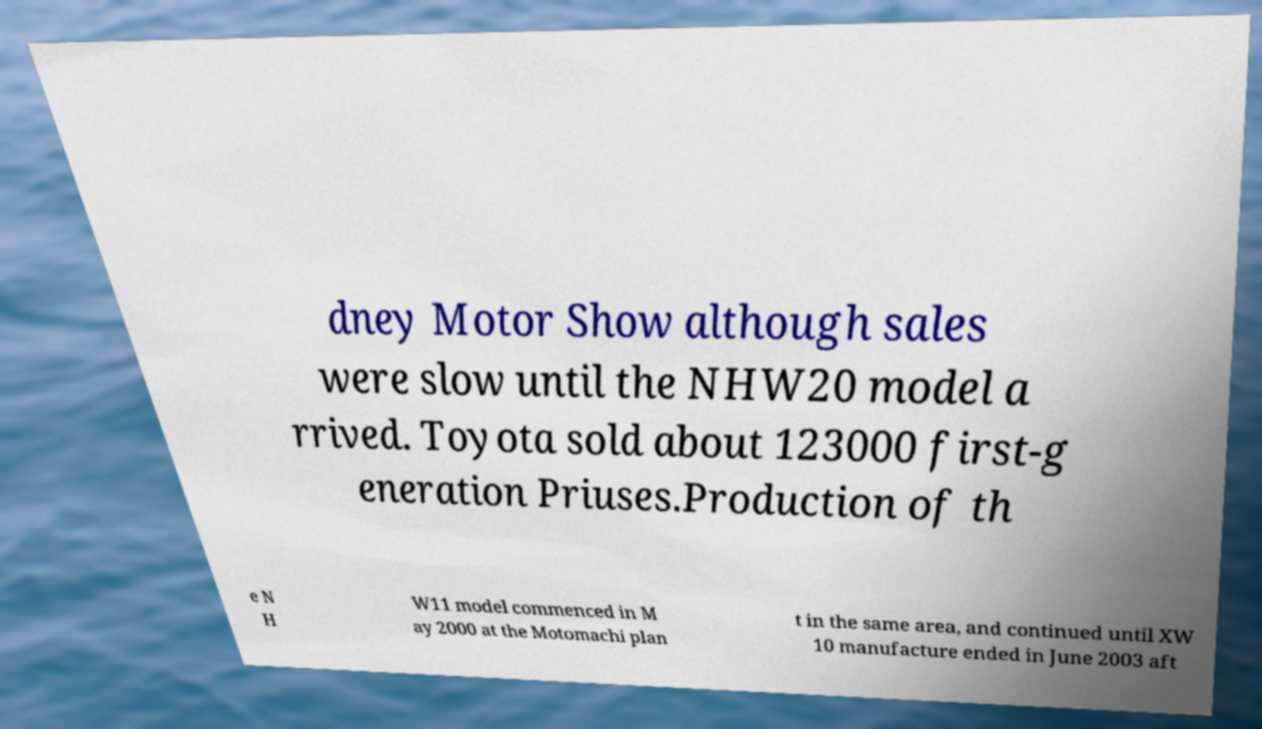Please identify and transcribe the text found in this image. dney Motor Show although sales were slow until the NHW20 model a rrived. Toyota sold about 123000 first-g eneration Priuses.Production of th e N H W11 model commenced in M ay 2000 at the Motomachi plan t in the same area, and continued until XW 10 manufacture ended in June 2003 aft 